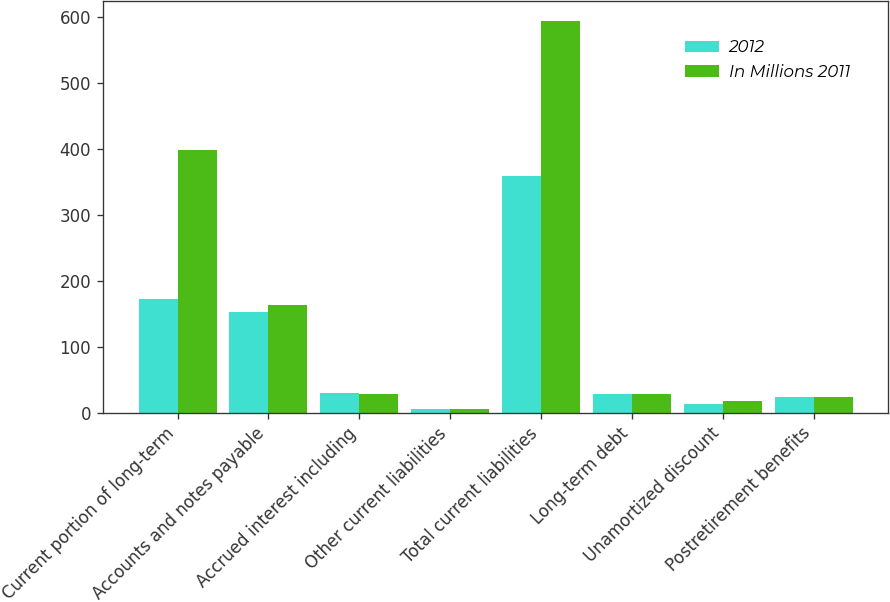<chart> <loc_0><loc_0><loc_500><loc_500><stacked_bar_chart><ecel><fcel>Current portion of long-term<fcel>Accounts and notes payable<fcel>Accrued interest including<fcel>Other current liabilities<fcel>Total current liabilities<fcel>Long-term debt<fcel>Unamortized discount<fcel>Postretirement benefits<nl><fcel>2012<fcel>172<fcel>152<fcel>30<fcel>5<fcel>359<fcel>29<fcel>13<fcel>24<nl><fcel>In Millions 2011<fcel>398<fcel>163<fcel>28<fcel>5<fcel>594<fcel>29<fcel>17<fcel>24<nl></chart> 